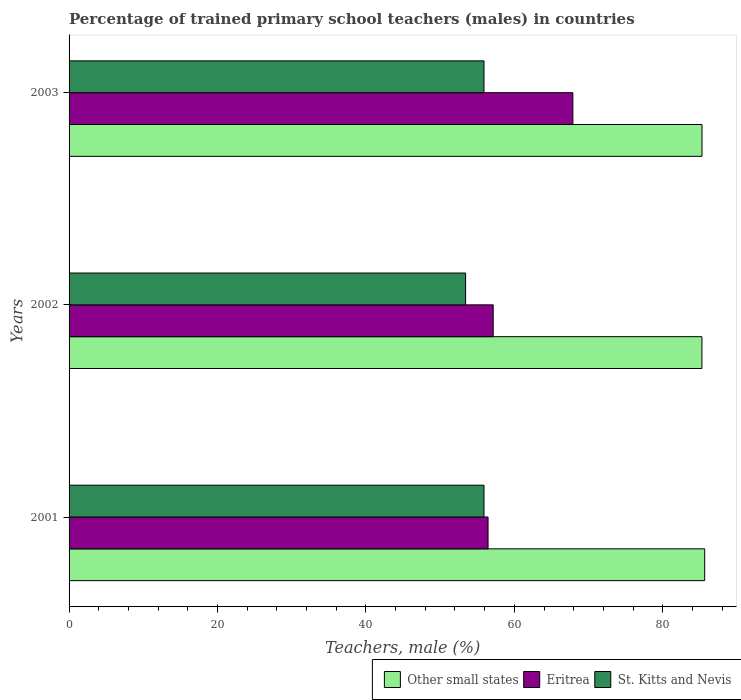How many different coloured bars are there?
Provide a succinct answer. 3. How many groups of bars are there?
Your answer should be very brief. 3. How many bars are there on the 3rd tick from the top?
Your answer should be compact. 3. How many bars are there on the 3rd tick from the bottom?
Ensure brevity in your answer.  3. What is the label of the 1st group of bars from the top?
Your response must be concise. 2003. What is the percentage of trained primary school teachers (males) in Eritrea in 2002?
Give a very brief answer. 57.15. Across all years, what is the maximum percentage of trained primary school teachers (males) in Other small states?
Keep it short and to the point. 85.65. Across all years, what is the minimum percentage of trained primary school teachers (males) in Other small states?
Provide a short and direct response. 85.28. In which year was the percentage of trained primary school teachers (males) in St. Kitts and Nevis minimum?
Give a very brief answer. 2002. What is the total percentage of trained primary school teachers (males) in Other small states in the graph?
Offer a very short reply. 256.22. What is the difference between the percentage of trained primary school teachers (males) in St. Kitts and Nevis in 2001 and that in 2003?
Give a very brief answer. 0. What is the difference between the percentage of trained primary school teachers (males) in Eritrea in 2001 and the percentage of trained primary school teachers (males) in St. Kitts and Nevis in 2002?
Provide a succinct answer. 3.02. What is the average percentage of trained primary school teachers (males) in Other small states per year?
Offer a terse response. 85.41. In the year 2003, what is the difference between the percentage of trained primary school teachers (males) in St. Kitts and Nevis and percentage of trained primary school teachers (males) in Eritrea?
Keep it short and to the point. -11.98. What is the ratio of the percentage of trained primary school teachers (males) in St. Kitts and Nevis in 2001 to that in 2003?
Provide a succinct answer. 1. Is the percentage of trained primary school teachers (males) in Other small states in 2002 less than that in 2003?
Your answer should be compact. Yes. Is the difference between the percentage of trained primary school teachers (males) in St. Kitts and Nevis in 2001 and 2003 greater than the difference between the percentage of trained primary school teachers (males) in Eritrea in 2001 and 2003?
Provide a short and direct response. Yes. What is the difference between the highest and the second highest percentage of trained primary school teachers (males) in Other small states?
Your answer should be very brief. 0.36. What is the difference between the highest and the lowest percentage of trained primary school teachers (males) in St. Kitts and Nevis?
Provide a succinct answer. 2.48. What does the 3rd bar from the top in 2003 represents?
Your answer should be very brief. Other small states. What does the 2nd bar from the bottom in 2001 represents?
Offer a very short reply. Eritrea. Is it the case that in every year, the sum of the percentage of trained primary school teachers (males) in St. Kitts and Nevis and percentage of trained primary school teachers (males) in Other small states is greater than the percentage of trained primary school teachers (males) in Eritrea?
Offer a terse response. Yes. What is the difference between two consecutive major ticks on the X-axis?
Your answer should be compact. 20. Does the graph contain any zero values?
Your response must be concise. No. Does the graph contain grids?
Your response must be concise. No. How are the legend labels stacked?
Make the answer very short. Horizontal. What is the title of the graph?
Keep it short and to the point. Percentage of trained primary school teachers (males) in countries. What is the label or title of the X-axis?
Provide a short and direct response. Teachers, male (%). What is the Teachers, male (%) in Other small states in 2001?
Ensure brevity in your answer.  85.65. What is the Teachers, male (%) of Eritrea in 2001?
Make the answer very short. 56.46. What is the Teachers, male (%) in St. Kitts and Nevis in 2001?
Your answer should be very brief. 55.91. What is the Teachers, male (%) in Other small states in 2002?
Your response must be concise. 85.28. What is the Teachers, male (%) of Eritrea in 2002?
Your answer should be very brief. 57.15. What is the Teachers, male (%) in St. Kitts and Nevis in 2002?
Offer a terse response. 53.43. What is the Teachers, male (%) in Other small states in 2003?
Offer a very short reply. 85.29. What is the Teachers, male (%) in Eritrea in 2003?
Provide a short and direct response. 67.89. What is the Teachers, male (%) in St. Kitts and Nevis in 2003?
Make the answer very short. 55.91. Across all years, what is the maximum Teachers, male (%) in Other small states?
Your answer should be compact. 85.65. Across all years, what is the maximum Teachers, male (%) in Eritrea?
Offer a terse response. 67.89. Across all years, what is the maximum Teachers, male (%) in St. Kitts and Nevis?
Provide a succinct answer. 55.91. Across all years, what is the minimum Teachers, male (%) of Other small states?
Make the answer very short. 85.28. Across all years, what is the minimum Teachers, male (%) of Eritrea?
Your answer should be compact. 56.46. Across all years, what is the minimum Teachers, male (%) in St. Kitts and Nevis?
Your answer should be very brief. 53.43. What is the total Teachers, male (%) in Other small states in the graph?
Give a very brief answer. 256.22. What is the total Teachers, male (%) in Eritrea in the graph?
Provide a short and direct response. 181.5. What is the total Teachers, male (%) of St. Kitts and Nevis in the graph?
Ensure brevity in your answer.  165.25. What is the difference between the Teachers, male (%) in Other small states in 2001 and that in 2002?
Keep it short and to the point. 0.38. What is the difference between the Teachers, male (%) in Eritrea in 2001 and that in 2002?
Your response must be concise. -0.7. What is the difference between the Teachers, male (%) in St. Kitts and Nevis in 2001 and that in 2002?
Give a very brief answer. 2.48. What is the difference between the Teachers, male (%) in Other small states in 2001 and that in 2003?
Give a very brief answer. 0.36. What is the difference between the Teachers, male (%) in Eritrea in 2001 and that in 2003?
Keep it short and to the point. -11.43. What is the difference between the Teachers, male (%) of Other small states in 2002 and that in 2003?
Provide a short and direct response. -0.01. What is the difference between the Teachers, male (%) in Eritrea in 2002 and that in 2003?
Offer a very short reply. -10.74. What is the difference between the Teachers, male (%) in St. Kitts and Nevis in 2002 and that in 2003?
Provide a succinct answer. -2.48. What is the difference between the Teachers, male (%) of Other small states in 2001 and the Teachers, male (%) of Eritrea in 2002?
Offer a very short reply. 28.5. What is the difference between the Teachers, male (%) in Other small states in 2001 and the Teachers, male (%) in St. Kitts and Nevis in 2002?
Make the answer very short. 32.22. What is the difference between the Teachers, male (%) of Eritrea in 2001 and the Teachers, male (%) of St. Kitts and Nevis in 2002?
Your answer should be compact. 3.02. What is the difference between the Teachers, male (%) in Other small states in 2001 and the Teachers, male (%) in Eritrea in 2003?
Make the answer very short. 17.77. What is the difference between the Teachers, male (%) of Other small states in 2001 and the Teachers, male (%) of St. Kitts and Nevis in 2003?
Offer a very short reply. 29.74. What is the difference between the Teachers, male (%) in Eritrea in 2001 and the Teachers, male (%) in St. Kitts and Nevis in 2003?
Provide a short and direct response. 0.55. What is the difference between the Teachers, male (%) in Other small states in 2002 and the Teachers, male (%) in Eritrea in 2003?
Your response must be concise. 17.39. What is the difference between the Teachers, male (%) in Other small states in 2002 and the Teachers, male (%) in St. Kitts and Nevis in 2003?
Offer a terse response. 29.37. What is the difference between the Teachers, male (%) in Eritrea in 2002 and the Teachers, male (%) in St. Kitts and Nevis in 2003?
Your answer should be very brief. 1.24. What is the average Teachers, male (%) of Other small states per year?
Provide a short and direct response. 85.41. What is the average Teachers, male (%) of Eritrea per year?
Your answer should be very brief. 60.5. What is the average Teachers, male (%) of St. Kitts and Nevis per year?
Your answer should be very brief. 55.08. In the year 2001, what is the difference between the Teachers, male (%) of Other small states and Teachers, male (%) of Eritrea?
Your response must be concise. 29.2. In the year 2001, what is the difference between the Teachers, male (%) of Other small states and Teachers, male (%) of St. Kitts and Nevis?
Offer a very short reply. 29.74. In the year 2001, what is the difference between the Teachers, male (%) of Eritrea and Teachers, male (%) of St. Kitts and Nevis?
Your answer should be very brief. 0.55. In the year 2002, what is the difference between the Teachers, male (%) of Other small states and Teachers, male (%) of Eritrea?
Provide a short and direct response. 28.13. In the year 2002, what is the difference between the Teachers, male (%) of Other small states and Teachers, male (%) of St. Kitts and Nevis?
Offer a terse response. 31.85. In the year 2002, what is the difference between the Teachers, male (%) in Eritrea and Teachers, male (%) in St. Kitts and Nevis?
Your answer should be very brief. 3.72. In the year 2003, what is the difference between the Teachers, male (%) of Other small states and Teachers, male (%) of Eritrea?
Offer a terse response. 17.4. In the year 2003, what is the difference between the Teachers, male (%) of Other small states and Teachers, male (%) of St. Kitts and Nevis?
Provide a succinct answer. 29.38. In the year 2003, what is the difference between the Teachers, male (%) of Eritrea and Teachers, male (%) of St. Kitts and Nevis?
Give a very brief answer. 11.98. What is the ratio of the Teachers, male (%) of Other small states in 2001 to that in 2002?
Provide a succinct answer. 1. What is the ratio of the Teachers, male (%) in Eritrea in 2001 to that in 2002?
Your answer should be very brief. 0.99. What is the ratio of the Teachers, male (%) in St. Kitts and Nevis in 2001 to that in 2002?
Offer a very short reply. 1.05. What is the ratio of the Teachers, male (%) in Eritrea in 2001 to that in 2003?
Offer a very short reply. 0.83. What is the ratio of the Teachers, male (%) in St. Kitts and Nevis in 2001 to that in 2003?
Provide a succinct answer. 1. What is the ratio of the Teachers, male (%) in Other small states in 2002 to that in 2003?
Your answer should be compact. 1. What is the ratio of the Teachers, male (%) in Eritrea in 2002 to that in 2003?
Provide a short and direct response. 0.84. What is the ratio of the Teachers, male (%) of St. Kitts and Nevis in 2002 to that in 2003?
Provide a short and direct response. 0.96. What is the difference between the highest and the second highest Teachers, male (%) in Other small states?
Provide a succinct answer. 0.36. What is the difference between the highest and the second highest Teachers, male (%) in Eritrea?
Ensure brevity in your answer.  10.74. What is the difference between the highest and the lowest Teachers, male (%) in Other small states?
Offer a terse response. 0.38. What is the difference between the highest and the lowest Teachers, male (%) of Eritrea?
Keep it short and to the point. 11.43. What is the difference between the highest and the lowest Teachers, male (%) of St. Kitts and Nevis?
Provide a succinct answer. 2.48. 